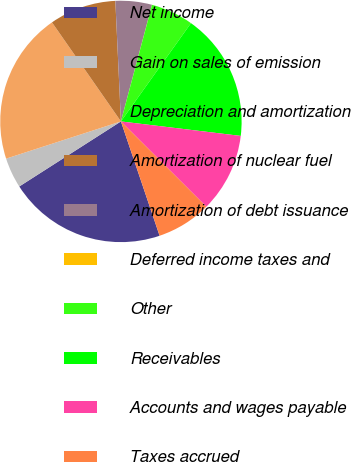Convert chart. <chart><loc_0><loc_0><loc_500><loc_500><pie_chart><fcel>Net income<fcel>Gain on sales of emission<fcel>Depreciation and amortization<fcel>Amortization of nuclear fuel<fcel>Amortization of debt issuance<fcel>Deferred income taxes and<fcel>Other<fcel>Receivables<fcel>Accounts and wages payable<fcel>Taxes accrued<nl><fcel>21.13%<fcel>4.07%<fcel>20.31%<fcel>8.94%<fcel>4.88%<fcel>0.01%<fcel>5.7%<fcel>17.06%<fcel>10.57%<fcel>7.32%<nl></chart> 